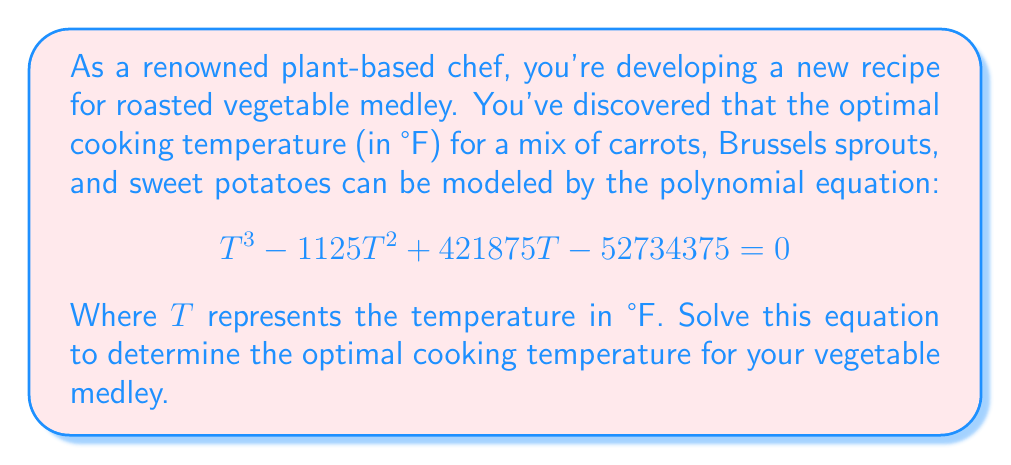Solve this math problem. To solve this cubic equation, we can use the rational root theorem and synthetic division.

1) First, let's find the possible rational roots. The factors of the constant term (52734375) are:
   $\pm 1, \pm 5, \pm 3125, \pm 15625, \pm 52734375$

2) We'll test these values using synthetic division, starting with 375 (as it's a common cooking temperature):

   $$
   \begin{array}{r}
   1 \quad -1125 \quad 421875 \quad -52734375 \\
   375 \quad 375 \quad -281250 \quad 52734375 \\
   \hline
   1 \quad -750 \quad 140625 \quad 0
   \end{array}
   $$

3) We found that 375 is a root of the equation. The polynomial can be factored as:

   $$(T - 375)(T^2 - 750T + 140625) = 0$$

4) We can solve the quadratic factor using the quadratic formula:

   $$T = \frac{-b \pm \sqrt{b^2 - 4ac}}{2a}$$

   Where $a=1$, $b=-750$, and $c=140625$

5) Substituting these values:

   $$T = \frac{750 \pm \sqrt{750^2 - 4(1)(140625)}}{2(1)}$$

   $$T = \frac{750 \pm \sqrt{562500 - 562500}}{2} = \frac{750 \pm 0}{2} = 375$$

6) Therefore, the only solution to this equation is 375°F.
Answer: The optimal cooking temperature for the vegetable medley is 375°F. 